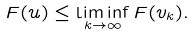<formula> <loc_0><loc_0><loc_500><loc_500>F ( u ) \leq \liminf _ { k \to \infty } F ( v _ { k } ) .</formula> 